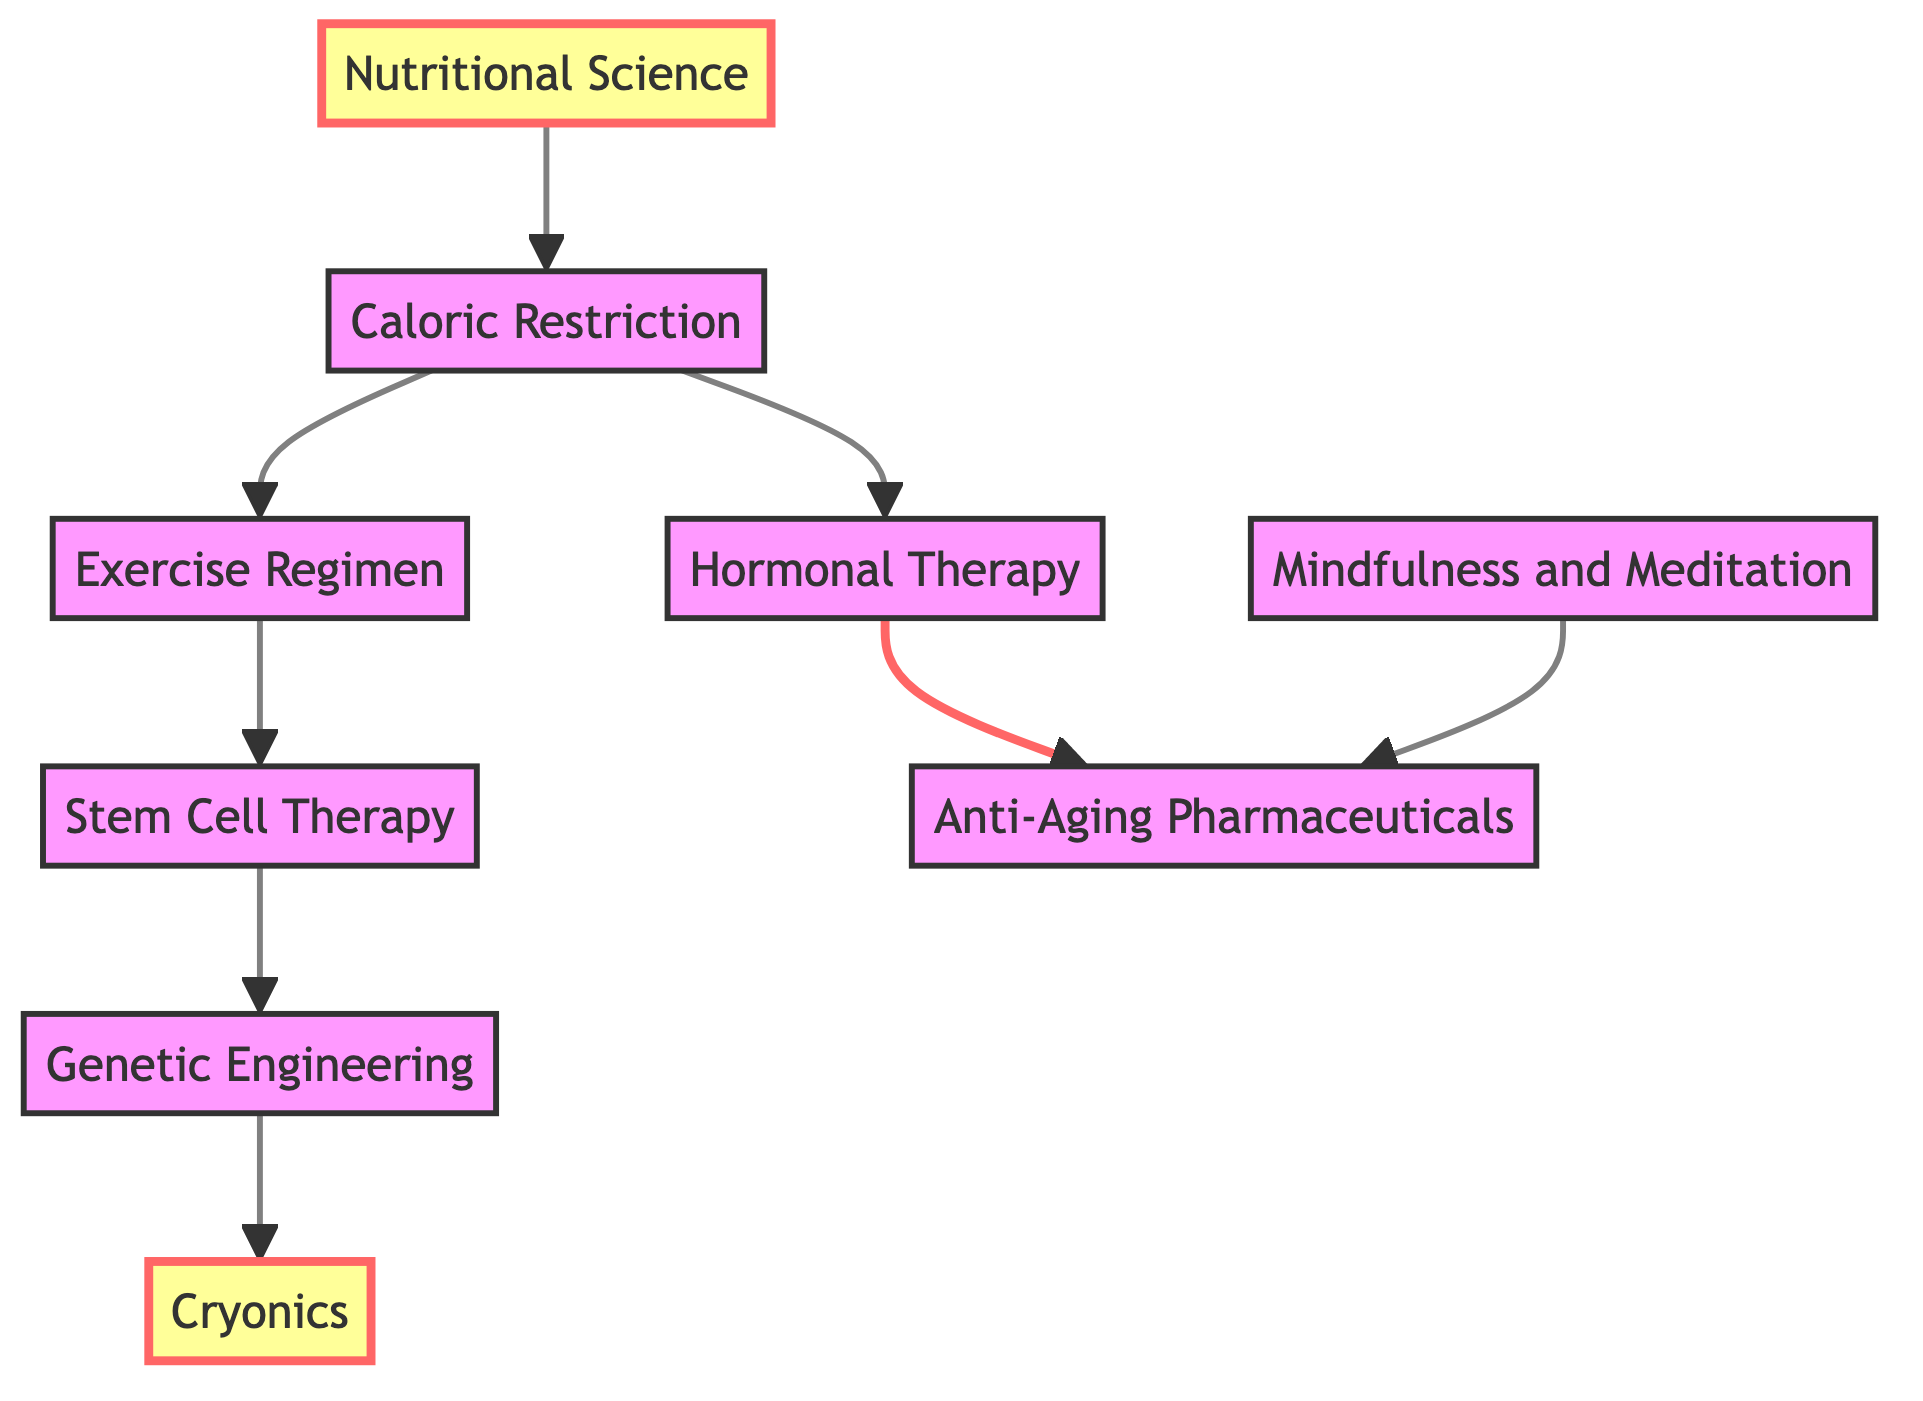What is the starting point in the pathway? The starting point in the diagram is "Nutritional Science," which is the first node connected to the pathway.
Answer: Nutritional Science How many nodes are there in total? Counting each distinct node listed in the diagram, there are 9 nodes.
Answer: 9 What is the end point of the pathway? The end point in the diagram is "Cryonics," which is the final node that one can reach following the directed edges.
Answer: Cryonics Which treatment follows Caloric Restriction? Based on the directed flow from "Caloric Restriction," the subsequent treatments are "Exercise Regimen" and "Hormonal Therapy". Both treatments are connected directly to it.
Answer: Exercise Regimen, Hormonal Therapy What treatments lead to Anti-Aging Pharmaceuticals? The pathway shows that "Hormonal Therapy" leads directly to "Anti-Aging Pharmaceuticals."
Answer: Hormonal Therapy Which node has the most edges directed towards it? Analyzing the directed edges, "Anti-Aging Pharmaceuticals" is connected to "Hormonal Therapy" and "Mindfulness and Meditation," receiving edges from two different nodes.
Answer: Anti-Aging Pharmaceuticals What is the relationship between Stem Cell Therapy and Genetic Engineering? According to the diagram, "Stem Cell Therapy" has a direct edge leading to "Genetic Engineering," indicating a sequential treatment or development between these two nodes.
Answer: Direct Which two nodes can reach Cryonics directly? The nodes "Genetic Engineering” and “Stem Cell Therapy" both have directed edges that can lead to "Cryonics."
Answer: Genetic Engineering, Stem Cell Therapy How does one arrive at Anti-Aging Pharmaceuticals? To reach "Anti-Aging Pharmaceuticals," one must first go through "Hormonal Therapy," which is connected to "Caloric Restriction," necessitating a prior pathway through "Nutritional Science."
Answer: Through Hormonal Therapy 